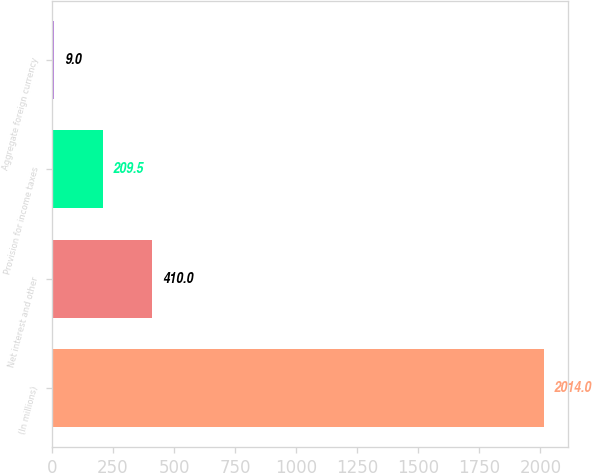Convert chart. <chart><loc_0><loc_0><loc_500><loc_500><bar_chart><fcel>(In millions)<fcel>Net interest and other<fcel>Provision for income taxes<fcel>Aggregate foreign currency<nl><fcel>2014<fcel>410<fcel>209.5<fcel>9<nl></chart> 